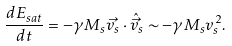<formula> <loc_0><loc_0><loc_500><loc_500>\frac { d E _ { s a t } } { d t } = - \gamma M _ { s } \vec { v _ { s } } \cdot \hat { \vec { v } } _ { s } \sim - \gamma M _ { s } v _ { s } ^ { 2 } .</formula> 